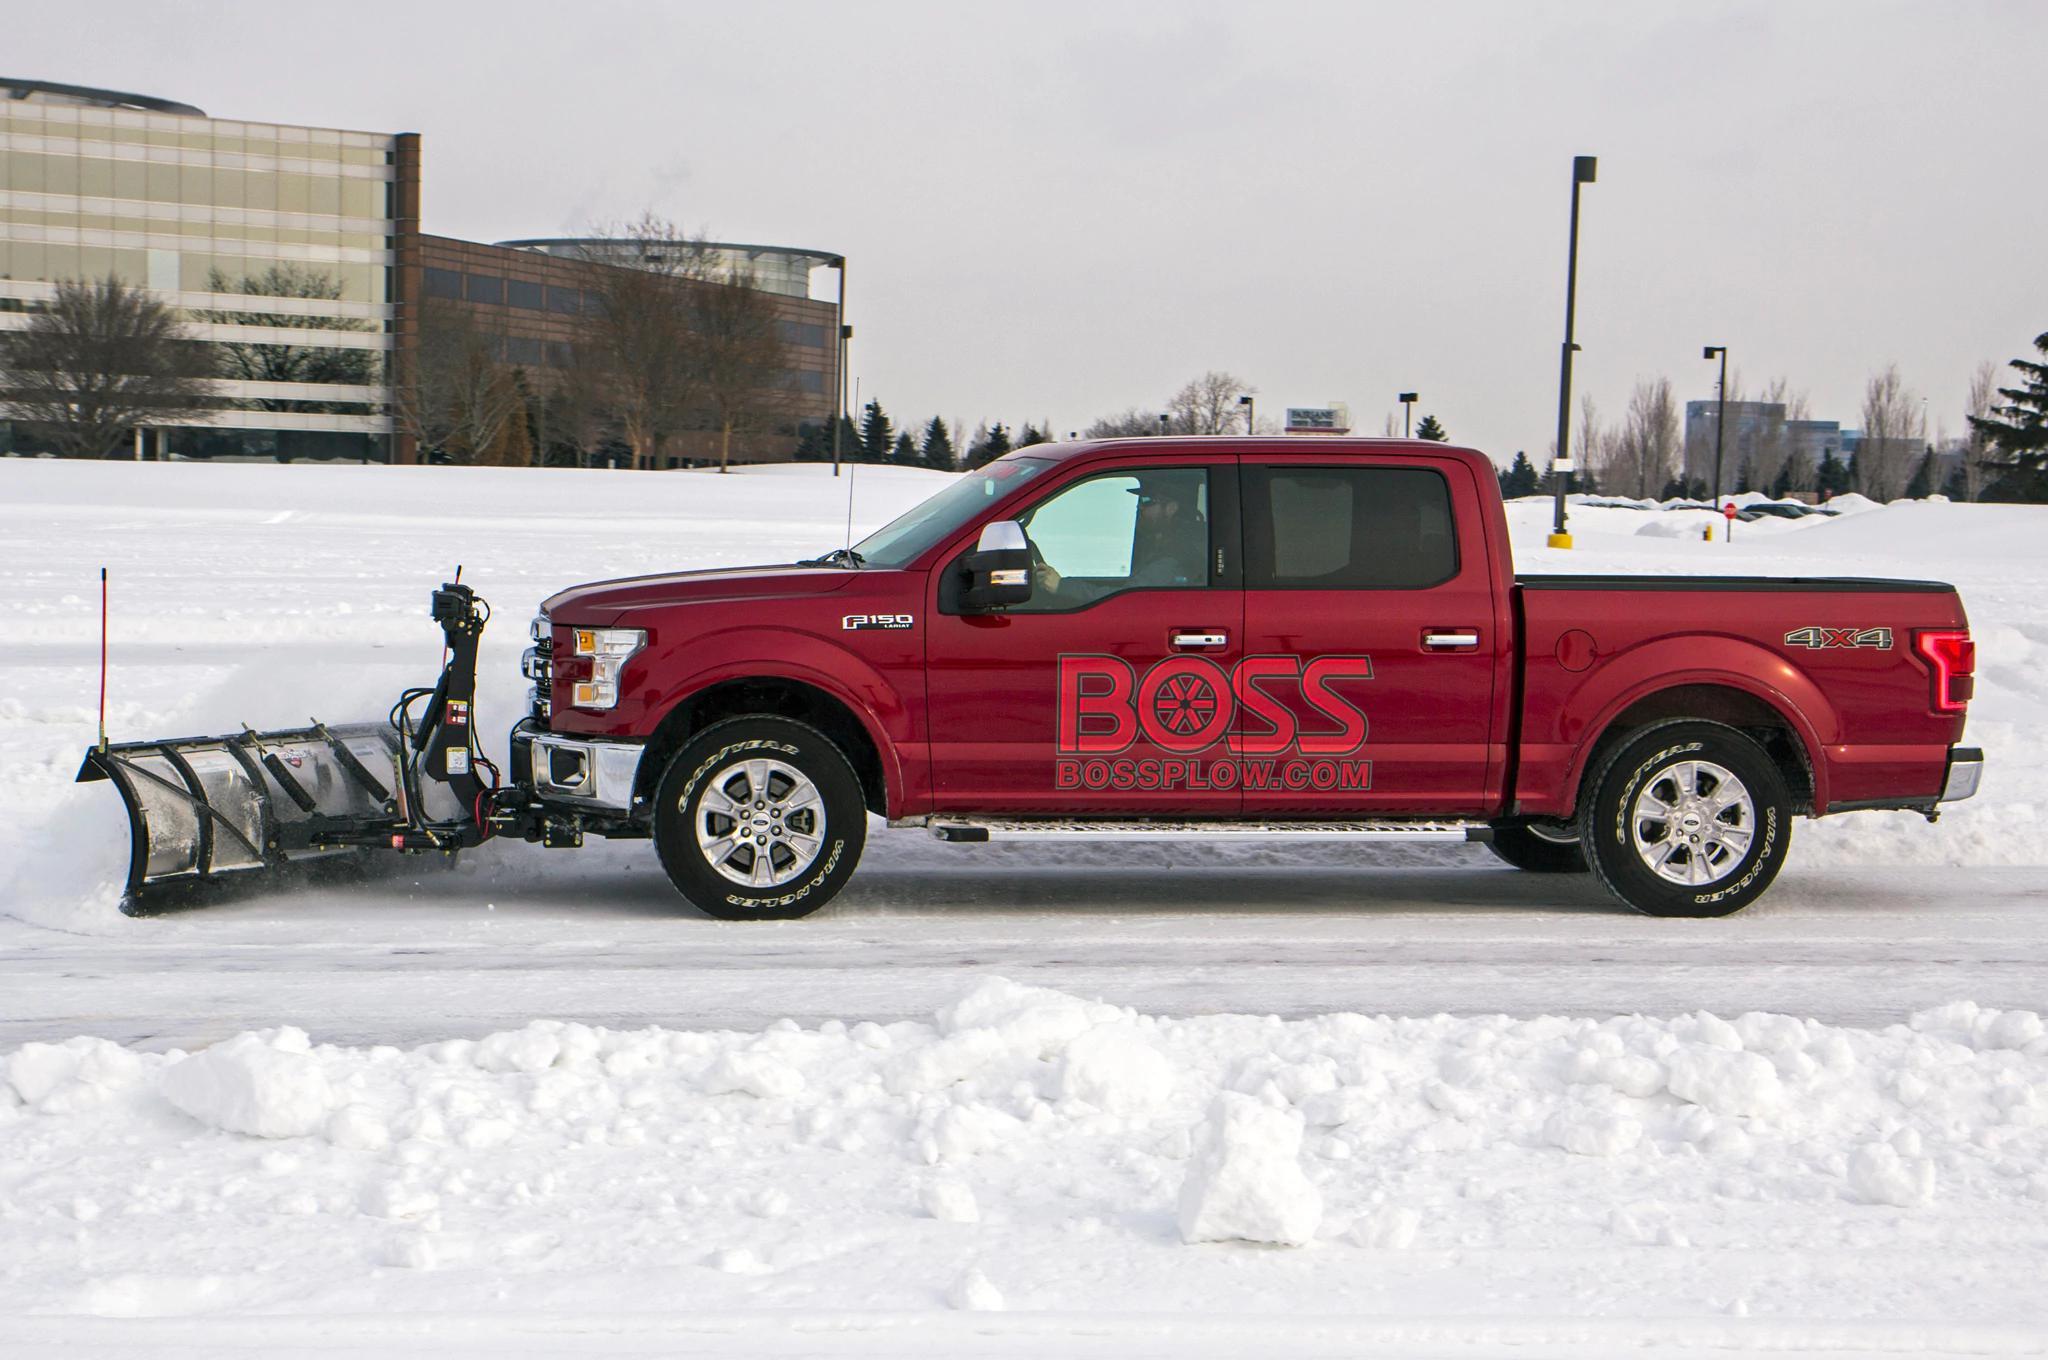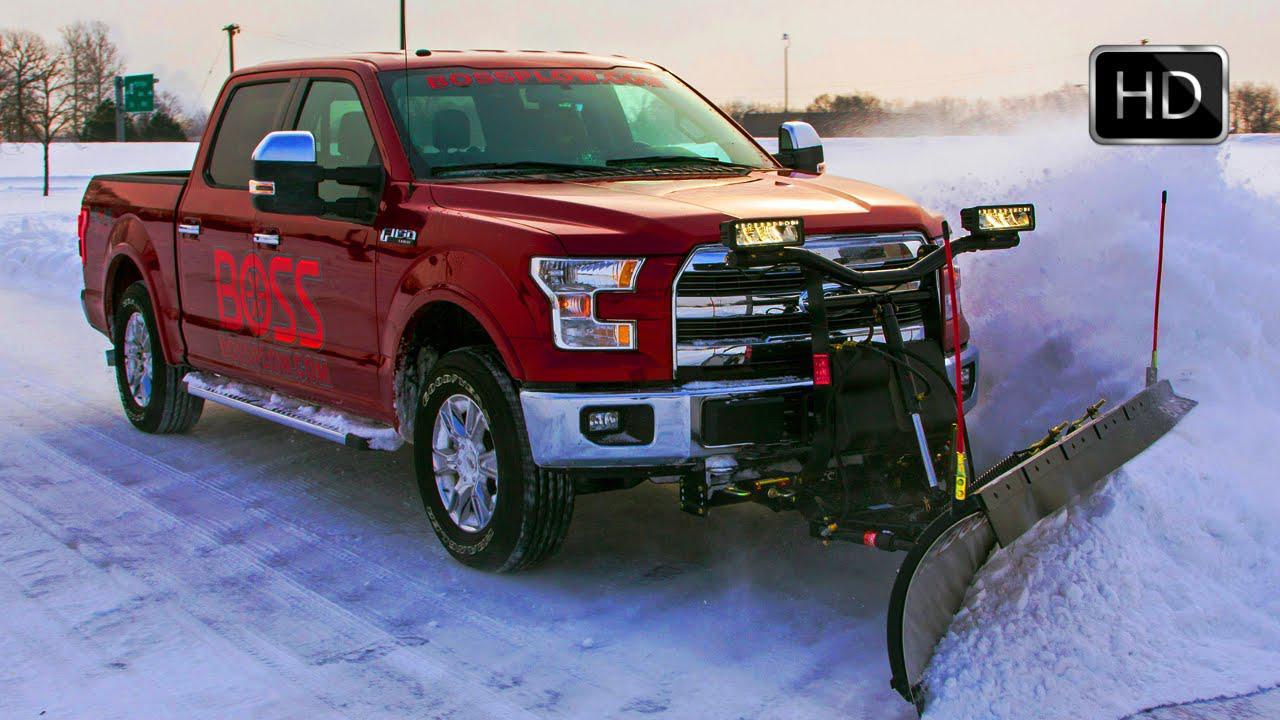The first image is the image on the left, the second image is the image on the right. Examine the images to the left and right. Is the description "One or more of the plows shown are pushing snow." accurate? Answer yes or no. Yes. The first image is the image on the left, the second image is the image on the right. For the images displayed, is the sentence "Right image shows a red truck with its plow pushing up snow." factually correct? Answer yes or no. Yes. 